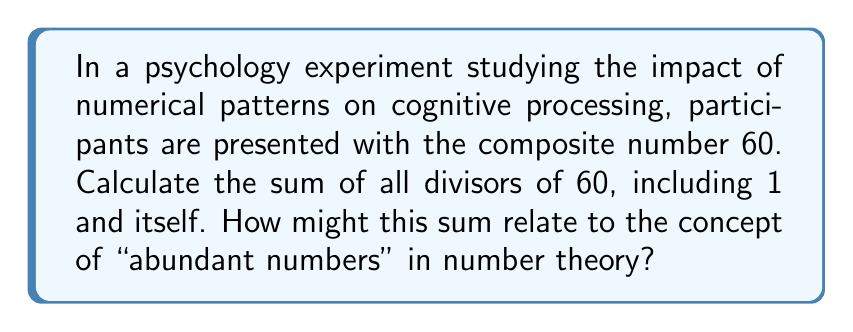Help me with this question. To find the sum of all divisors of 60, we'll follow these steps:

1) First, let's list all the divisors of 60:
   $1, 2, 3, 4, 5, 6, 10, 12, 15, 20, 30, 60$

2) Now, we'll add these numbers:

   $$1 + 2 + 3 + 4 + 5 + 6 + 10 + 12 + 15 + 20 + 30 + 60 = 168$$

3) The sum of all divisors of 60 is 168.

4) To understand how this relates to abundant numbers:
   - An abundant number is a positive integer for which the sum of its proper divisors (divisors excluding the number itself) is greater than the number.
   - The sum of proper divisors of 60 is: $168 - 60 = 108$
   - Since $108 > 60$, 60 is an abundant number.

This concept could be used in psychology research to study how recognition of mathematical patterns might influence cognitive processing or decision-making.
Answer: 168; 60 is an abundant number 